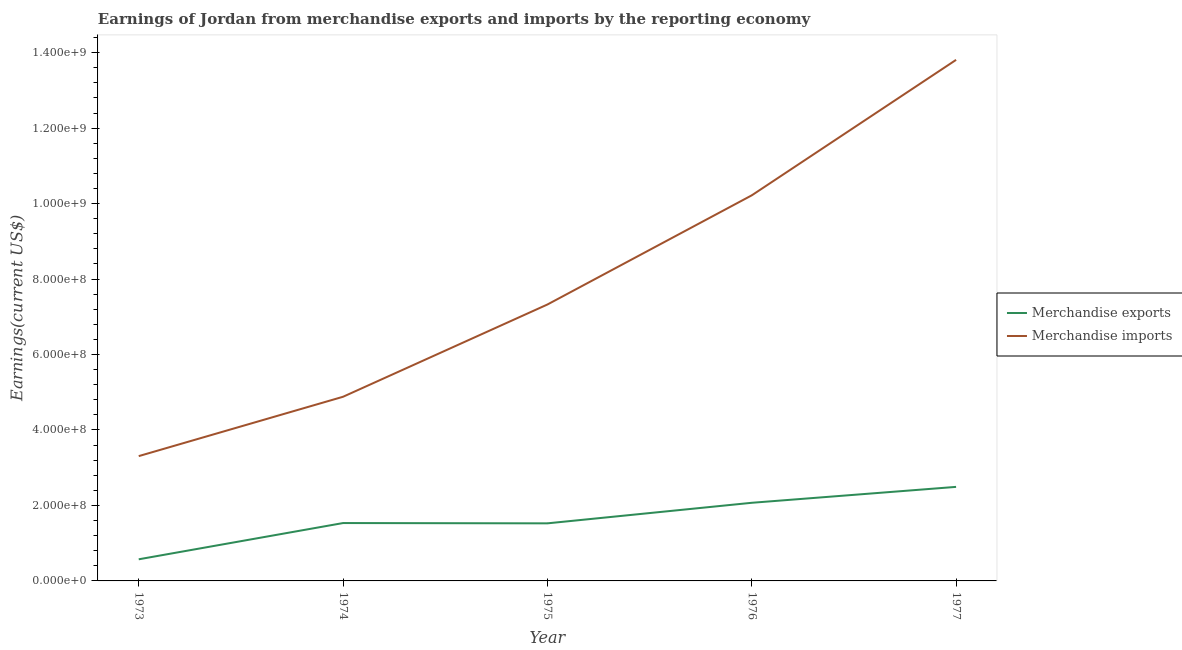How many different coloured lines are there?
Offer a terse response. 2. Does the line corresponding to earnings from merchandise imports intersect with the line corresponding to earnings from merchandise exports?
Keep it short and to the point. No. What is the earnings from merchandise exports in 1976?
Provide a short and direct response. 2.07e+08. Across all years, what is the maximum earnings from merchandise exports?
Your answer should be very brief. 2.49e+08. Across all years, what is the minimum earnings from merchandise exports?
Provide a succinct answer. 5.73e+07. In which year was the earnings from merchandise exports maximum?
Your answer should be very brief. 1977. In which year was the earnings from merchandise exports minimum?
Provide a short and direct response. 1973. What is the total earnings from merchandise imports in the graph?
Make the answer very short. 3.95e+09. What is the difference between the earnings from merchandise imports in 1973 and that in 1976?
Offer a terse response. -6.91e+08. What is the difference between the earnings from merchandise exports in 1974 and the earnings from merchandise imports in 1973?
Offer a very short reply. -1.77e+08. What is the average earnings from merchandise exports per year?
Ensure brevity in your answer.  1.64e+08. In the year 1973, what is the difference between the earnings from merchandise exports and earnings from merchandise imports?
Offer a very short reply. -2.73e+08. What is the ratio of the earnings from merchandise exports in 1976 to that in 1977?
Give a very brief answer. 0.83. Is the earnings from merchandise imports in 1975 less than that in 1976?
Ensure brevity in your answer.  Yes. Is the difference between the earnings from merchandise exports in 1975 and 1976 greater than the difference between the earnings from merchandise imports in 1975 and 1976?
Keep it short and to the point. Yes. What is the difference between the highest and the second highest earnings from merchandise exports?
Offer a very short reply. 4.22e+07. What is the difference between the highest and the lowest earnings from merchandise imports?
Ensure brevity in your answer.  1.05e+09. In how many years, is the earnings from merchandise imports greater than the average earnings from merchandise imports taken over all years?
Make the answer very short. 2. Is the earnings from merchandise imports strictly less than the earnings from merchandise exports over the years?
Give a very brief answer. No. How many years are there in the graph?
Provide a succinct answer. 5. What is the difference between two consecutive major ticks on the Y-axis?
Ensure brevity in your answer.  2.00e+08. Does the graph contain any zero values?
Give a very brief answer. No. Where does the legend appear in the graph?
Your answer should be very brief. Center right. How many legend labels are there?
Your answer should be compact. 2. How are the legend labels stacked?
Keep it short and to the point. Vertical. What is the title of the graph?
Your response must be concise. Earnings of Jordan from merchandise exports and imports by the reporting economy. Does "Urban" appear as one of the legend labels in the graph?
Offer a terse response. No. What is the label or title of the X-axis?
Offer a very short reply. Year. What is the label or title of the Y-axis?
Your response must be concise. Earnings(current US$). What is the Earnings(current US$) of Merchandise exports in 1973?
Your answer should be compact. 5.73e+07. What is the Earnings(current US$) of Merchandise imports in 1973?
Offer a very short reply. 3.31e+08. What is the Earnings(current US$) of Merchandise exports in 1974?
Give a very brief answer. 1.53e+08. What is the Earnings(current US$) of Merchandise imports in 1974?
Ensure brevity in your answer.  4.88e+08. What is the Earnings(current US$) in Merchandise exports in 1975?
Keep it short and to the point. 1.53e+08. What is the Earnings(current US$) of Merchandise imports in 1975?
Provide a succinct answer. 7.33e+08. What is the Earnings(current US$) in Merchandise exports in 1976?
Offer a terse response. 2.07e+08. What is the Earnings(current US$) of Merchandise imports in 1976?
Make the answer very short. 1.02e+09. What is the Earnings(current US$) in Merchandise exports in 1977?
Your answer should be compact. 2.49e+08. What is the Earnings(current US$) in Merchandise imports in 1977?
Provide a short and direct response. 1.38e+09. Across all years, what is the maximum Earnings(current US$) of Merchandise exports?
Provide a short and direct response. 2.49e+08. Across all years, what is the maximum Earnings(current US$) in Merchandise imports?
Your answer should be compact. 1.38e+09. Across all years, what is the minimum Earnings(current US$) of Merchandise exports?
Provide a succinct answer. 5.73e+07. Across all years, what is the minimum Earnings(current US$) of Merchandise imports?
Make the answer very short. 3.31e+08. What is the total Earnings(current US$) in Merchandise exports in the graph?
Make the answer very short. 8.20e+08. What is the total Earnings(current US$) of Merchandise imports in the graph?
Provide a short and direct response. 3.95e+09. What is the difference between the Earnings(current US$) in Merchandise exports in 1973 and that in 1974?
Make the answer very short. -9.60e+07. What is the difference between the Earnings(current US$) of Merchandise imports in 1973 and that in 1974?
Give a very brief answer. -1.57e+08. What is the difference between the Earnings(current US$) in Merchandise exports in 1973 and that in 1975?
Make the answer very short. -9.53e+07. What is the difference between the Earnings(current US$) in Merchandise imports in 1973 and that in 1975?
Your answer should be very brief. -4.02e+08. What is the difference between the Earnings(current US$) in Merchandise exports in 1973 and that in 1976?
Make the answer very short. -1.50e+08. What is the difference between the Earnings(current US$) of Merchandise imports in 1973 and that in 1976?
Make the answer very short. -6.91e+08. What is the difference between the Earnings(current US$) of Merchandise exports in 1973 and that in 1977?
Keep it short and to the point. -1.92e+08. What is the difference between the Earnings(current US$) of Merchandise imports in 1973 and that in 1977?
Your answer should be compact. -1.05e+09. What is the difference between the Earnings(current US$) of Merchandise exports in 1974 and that in 1975?
Your answer should be compact. 7.70e+05. What is the difference between the Earnings(current US$) of Merchandise imports in 1974 and that in 1975?
Give a very brief answer. -2.44e+08. What is the difference between the Earnings(current US$) of Merchandise exports in 1974 and that in 1976?
Provide a short and direct response. -5.37e+07. What is the difference between the Earnings(current US$) in Merchandise imports in 1974 and that in 1976?
Give a very brief answer. -5.34e+08. What is the difference between the Earnings(current US$) of Merchandise exports in 1974 and that in 1977?
Offer a terse response. -9.59e+07. What is the difference between the Earnings(current US$) of Merchandise imports in 1974 and that in 1977?
Keep it short and to the point. -8.93e+08. What is the difference between the Earnings(current US$) in Merchandise exports in 1975 and that in 1976?
Your answer should be compact. -5.45e+07. What is the difference between the Earnings(current US$) in Merchandise imports in 1975 and that in 1976?
Offer a terse response. -2.89e+08. What is the difference between the Earnings(current US$) in Merchandise exports in 1975 and that in 1977?
Make the answer very short. -9.66e+07. What is the difference between the Earnings(current US$) in Merchandise imports in 1975 and that in 1977?
Offer a very short reply. -6.48e+08. What is the difference between the Earnings(current US$) in Merchandise exports in 1976 and that in 1977?
Keep it short and to the point. -4.22e+07. What is the difference between the Earnings(current US$) in Merchandise imports in 1976 and that in 1977?
Your response must be concise. -3.59e+08. What is the difference between the Earnings(current US$) of Merchandise exports in 1973 and the Earnings(current US$) of Merchandise imports in 1974?
Make the answer very short. -4.31e+08. What is the difference between the Earnings(current US$) of Merchandise exports in 1973 and the Earnings(current US$) of Merchandise imports in 1975?
Your answer should be very brief. -6.75e+08. What is the difference between the Earnings(current US$) in Merchandise exports in 1973 and the Earnings(current US$) in Merchandise imports in 1976?
Your answer should be compact. -9.65e+08. What is the difference between the Earnings(current US$) of Merchandise exports in 1973 and the Earnings(current US$) of Merchandise imports in 1977?
Provide a short and direct response. -1.32e+09. What is the difference between the Earnings(current US$) of Merchandise exports in 1974 and the Earnings(current US$) of Merchandise imports in 1975?
Your response must be concise. -5.79e+08. What is the difference between the Earnings(current US$) of Merchandise exports in 1974 and the Earnings(current US$) of Merchandise imports in 1976?
Provide a short and direct response. -8.69e+08. What is the difference between the Earnings(current US$) of Merchandise exports in 1974 and the Earnings(current US$) of Merchandise imports in 1977?
Make the answer very short. -1.23e+09. What is the difference between the Earnings(current US$) in Merchandise exports in 1975 and the Earnings(current US$) in Merchandise imports in 1976?
Your answer should be compact. -8.69e+08. What is the difference between the Earnings(current US$) of Merchandise exports in 1975 and the Earnings(current US$) of Merchandise imports in 1977?
Your answer should be very brief. -1.23e+09. What is the difference between the Earnings(current US$) of Merchandise exports in 1976 and the Earnings(current US$) of Merchandise imports in 1977?
Your answer should be very brief. -1.17e+09. What is the average Earnings(current US$) of Merchandise exports per year?
Give a very brief answer. 1.64e+08. What is the average Earnings(current US$) in Merchandise imports per year?
Your response must be concise. 7.91e+08. In the year 1973, what is the difference between the Earnings(current US$) in Merchandise exports and Earnings(current US$) in Merchandise imports?
Your response must be concise. -2.73e+08. In the year 1974, what is the difference between the Earnings(current US$) of Merchandise exports and Earnings(current US$) of Merchandise imports?
Offer a terse response. -3.35e+08. In the year 1975, what is the difference between the Earnings(current US$) in Merchandise exports and Earnings(current US$) in Merchandise imports?
Offer a terse response. -5.80e+08. In the year 1976, what is the difference between the Earnings(current US$) of Merchandise exports and Earnings(current US$) of Merchandise imports?
Give a very brief answer. -8.15e+08. In the year 1977, what is the difference between the Earnings(current US$) in Merchandise exports and Earnings(current US$) in Merchandise imports?
Your answer should be compact. -1.13e+09. What is the ratio of the Earnings(current US$) of Merchandise exports in 1973 to that in 1974?
Provide a succinct answer. 0.37. What is the ratio of the Earnings(current US$) in Merchandise imports in 1973 to that in 1974?
Offer a terse response. 0.68. What is the ratio of the Earnings(current US$) of Merchandise exports in 1973 to that in 1975?
Make the answer very short. 0.38. What is the ratio of the Earnings(current US$) in Merchandise imports in 1973 to that in 1975?
Your answer should be compact. 0.45. What is the ratio of the Earnings(current US$) in Merchandise exports in 1973 to that in 1976?
Ensure brevity in your answer.  0.28. What is the ratio of the Earnings(current US$) of Merchandise imports in 1973 to that in 1976?
Keep it short and to the point. 0.32. What is the ratio of the Earnings(current US$) in Merchandise exports in 1973 to that in 1977?
Offer a terse response. 0.23. What is the ratio of the Earnings(current US$) of Merchandise imports in 1973 to that in 1977?
Give a very brief answer. 0.24. What is the ratio of the Earnings(current US$) in Merchandise imports in 1974 to that in 1975?
Keep it short and to the point. 0.67. What is the ratio of the Earnings(current US$) in Merchandise exports in 1974 to that in 1976?
Offer a very short reply. 0.74. What is the ratio of the Earnings(current US$) in Merchandise imports in 1974 to that in 1976?
Ensure brevity in your answer.  0.48. What is the ratio of the Earnings(current US$) in Merchandise exports in 1974 to that in 1977?
Offer a very short reply. 0.62. What is the ratio of the Earnings(current US$) of Merchandise imports in 1974 to that in 1977?
Your response must be concise. 0.35. What is the ratio of the Earnings(current US$) of Merchandise exports in 1975 to that in 1976?
Keep it short and to the point. 0.74. What is the ratio of the Earnings(current US$) of Merchandise imports in 1975 to that in 1976?
Ensure brevity in your answer.  0.72. What is the ratio of the Earnings(current US$) of Merchandise exports in 1975 to that in 1977?
Offer a terse response. 0.61. What is the ratio of the Earnings(current US$) of Merchandise imports in 1975 to that in 1977?
Ensure brevity in your answer.  0.53. What is the ratio of the Earnings(current US$) of Merchandise exports in 1976 to that in 1977?
Your response must be concise. 0.83. What is the ratio of the Earnings(current US$) of Merchandise imports in 1976 to that in 1977?
Your response must be concise. 0.74. What is the difference between the highest and the second highest Earnings(current US$) in Merchandise exports?
Make the answer very short. 4.22e+07. What is the difference between the highest and the second highest Earnings(current US$) of Merchandise imports?
Provide a short and direct response. 3.59e+08. What is the difference between the highest and the lowest Earnings(current US$) in Merchandise exports?
Ensure brevity in your answer.  1.92e+08. What is the difference between the highest and the lowest Earnings(current US$) in Merchandise imports?
Your answer should be very brief. 1.05e+09. 